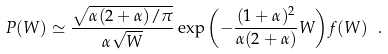<formula> <loc_0><loc_0><loc_500><loc_500>P ( W ) \simeq \frac { \sqrt { \alpha ( 2 + \alpha ) / \pi } } { \alpha \sqrt { W } } \exp { \left ( - \frac { ( 1 + \alpha ) ^ { 2 } } { \alpha ( 2 + \alpha ) } W \right ) } f ( W ) \ .</formula> 